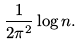<formula> <loc_0><loc_0><loc_500><loc_500>\frac { 1 } { 2 \pi ^ { 2 } } \log n .</formula> 